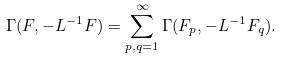<formula> <loc_0><loc_0><loc_500><loc_500>\Gamma ( F , - L ^ { - 1 } F ) = \sum _ { p , q = 1 } ^ { \infty } \Gamma ( F _ { p } , - L ^ { - 1 } F _ { q } ) .</formula> 